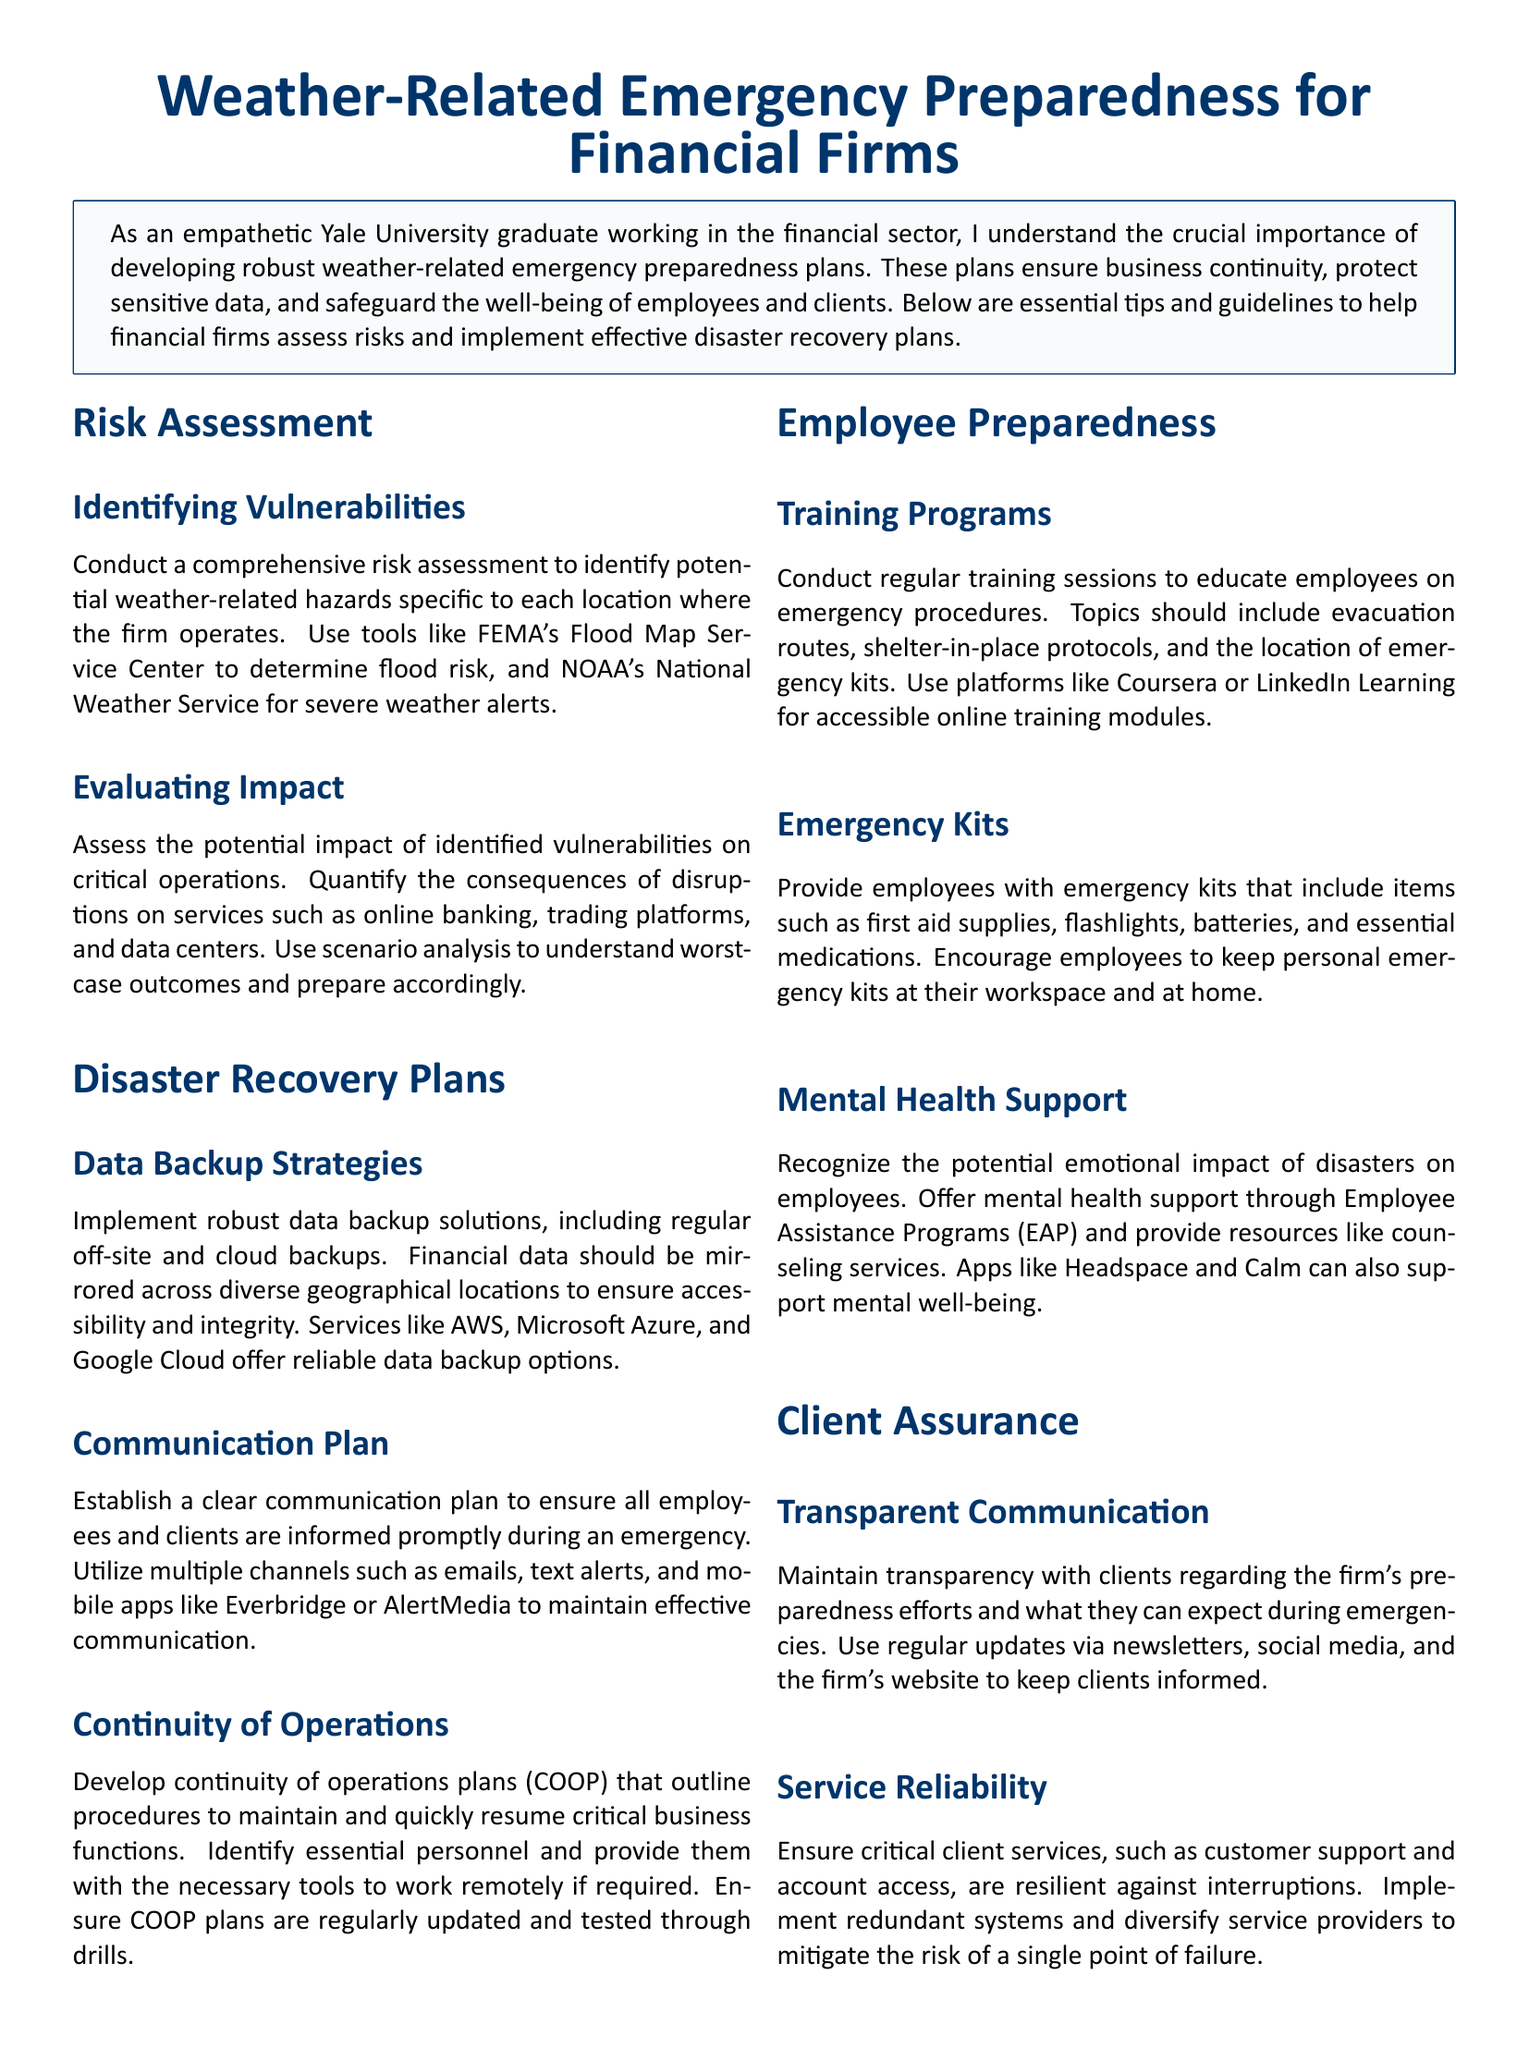What is the main topic of the document? The main topic of the document is explicitly stated in the title, which focuses on weather-related emergency preparedness for financial firms.
Answer: Weather-Related Emergency Preparedness for Financial Firms What tool is recommended for determining flood risk? The document mentions FEMA's Flood Map Service Center as a tool for determining flood risk.
Answer: FEMA's Flood Map Service Center What does COOP stand for? Within the document, COOP is defined as Continuity of Operations Plans.
Answer: Continuity of Operations Plans What is one recommended data backup solution? The document lists AWS as one of the reliable data backup options for financial firms.
Answer: AWS What is a key component of a communication plan during an emergency? The document emphasizes the importance of utilizing multiple channels for communication during an emergency.
Answer: Multiple channels How often should employee training sessions be conducted? The document suggests conducting regular training sessions for employees on emergency procedures.
Answer: Regularly What resource does the document suggest for mental health support? The document points to Employee Assistance Programs (EAP) as a resource for mental health support.
Answer: Employee Assistance Programs What type of items should be included in employee emergency kits? Items such as first aid supplies and flashlights are recommended to be included in emergency kits.
Answer: First aid supplies, flashlights How can financial firms maintain transparency with clients? The document advises using regular updates via newsletters and social media to keep clients informed.
Answer: Regular updates via newsletters and social media 